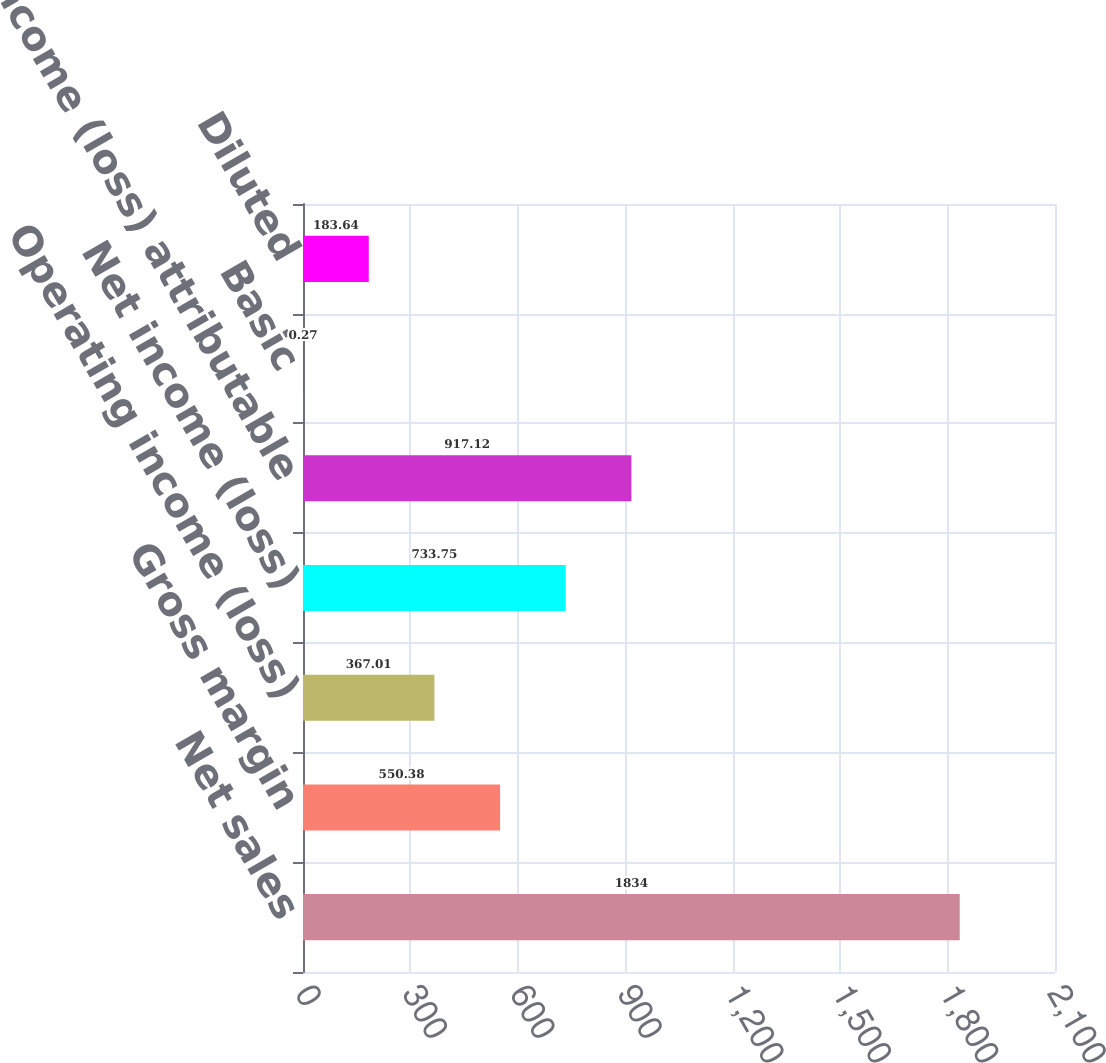Convert chart to OTSL. <chart><loc_0><loc_0><loc_500><loc_500><bar_chart><fcel>Net sales<fcel>Gross margin<fcel>Operating income (loss)<fcel>Net income (loss)<fcel>Net income (loss) attributable<fcel>Basic<fcel>Diluted<nl><fcel>1834<fcel>550.38<fcel>367.01<fcel>733.75<fcel>917.12<fcel>0.27<fcel>183.64<nl></chart> 